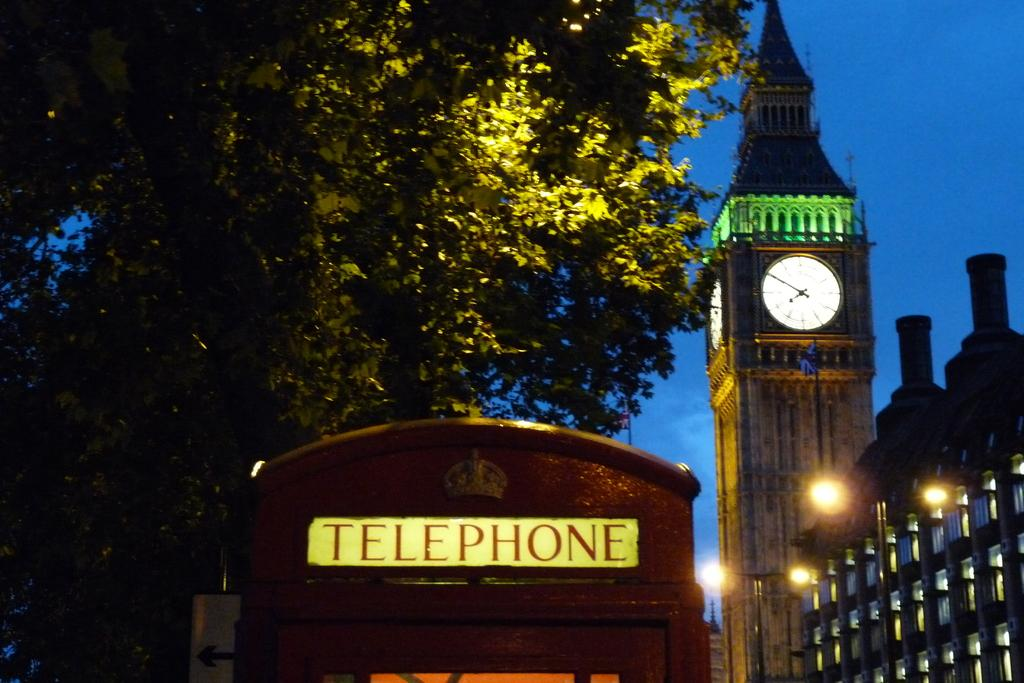Provide a one-sentence caption for the provided image. A telephone booth is in the foreground and in the background is Big Ben the famous London clock tower lit up in green at night. 